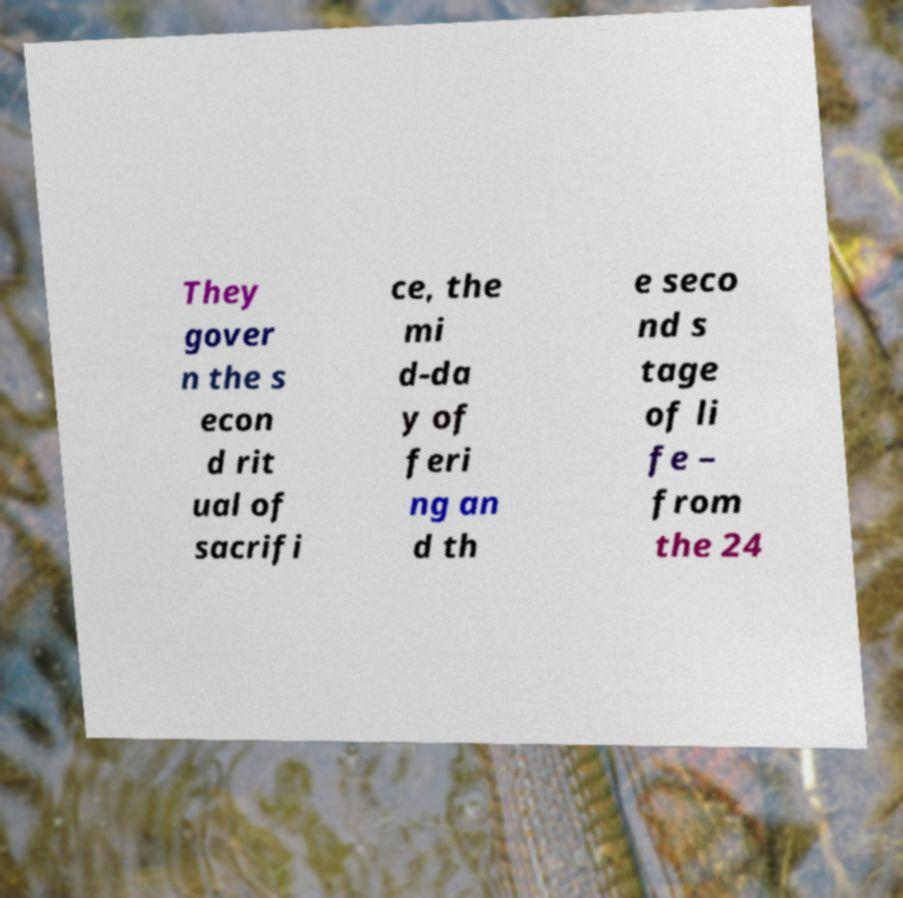There's text embedded in this image that I need extracted. Can you transcribe it verbatim? They gover n the s econ d rit ual of sacrifi ce, the mi d-da y of feri ng an d th e seco nd s tage of li fe – from the 24 